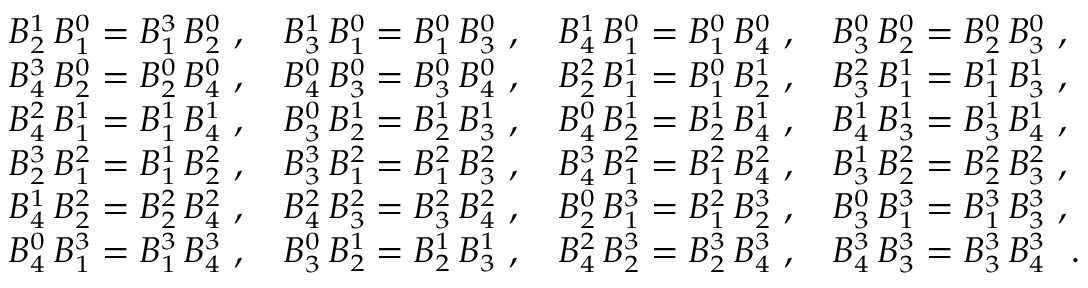Convert formula to latex. <formula><loc_0><loc_0><loc_500><loc_500>{ \begin{array} { l l l l } { B _ { 2 } ^ { 1 } \, B _ { 1 } ^ { 0 } = B _ { 1 } ^ { 3 } \, B _ { 2 } ^ { 0 } \ , } & { B _ { 3 } ^ { 1 } \, B _ { 1 } ^ { 0 } = B _ { 1 } ^ { 0 } \, B _ { 3 } ^ { 0 } \ , } & { B _ { 4 } ^ { 1 } \, B _ { 1 } ^ { 0 } = B _ { 1 } ^ { 0 } \, B _ { 4 } ^ { 0 } \ , } & { B _ { 3 } ^ { 0 } \, B _ { 2 } ^ { 0 } = B _ { 2 } ^ { 0 } \, B _ { 3 } ^ { 0 } \ , } \\ { B _ { 4 } ^ { 3 } \, B _ { 2 } ^ { 0 } = B _ { 2 } ^ { 0 } \, B _ { 4 } ^ { 0 } \ , } & { B _ { 4 } ^ { 0 } \, B _ { 3 } ^ { 0 } = B _ { 3 } ^ { 0 } \, B _ { 4 } ^ { 0 } \ , } & { B _ { 2 } ^ { 2 } \, B _ { 1 } ^ { 1 } = B _ { 1 } ^ { 0 } \, B _ { 2 } ^ { 1 } \ , } & { B _ { 3 } ^ { 2 } \, B _ { 1 } ^ { 1 } = B _ { 1 } ^ { 1 } \, B _ { 3 } ^ { 1 } \ , } \\ { B _ { 4 } ^ { 2 } \, B _ { 1 } ^ { 1 } = B _ { 1 } ^ { 1 } \, B _ { 4 } ^ { 1 } \ , } & { B _ { 3 } ^ { 0 } \, B _ { 2 } ^ { 1 } = B _ { 2 } ^ { 1 } \, B _ { 3 } ^ { 1 } \ , } & { B _ { 4 } ^ { 0 } \, B _ { 2 } ^ { 1 } = B _ { 2 } ^ { 1 } \, B _ { 4 } ^ { 1 } \ , } & { B _ { 4 } ^ { 1 } \, B _ { 3 } ^ { 1 } = B _ { 3 } ^ { 1 } \, B _ { 4 } ^ { 1 } \ , } \\ { B _ { 2 } ^ { 3 } \, B _ { 1 } ^ { 2 } = B _ { 1 } ^ { 1 } \, B _ { 2 } ^ { 2 } \ , } & { B _ { 3 } ^ { 3 } \, B _ { 1 } ^ { 2 } = B _ { 1 } ^ { 2 } \, B _ { 3 } ^ { 2 } \ , } & { B _ { 4 } ^ { 3 } \, B _ { 1 } ^ { 2 } = B _ { 1 } ^ { 2 } \, B _ { 4 } ^ { 2 } \ , } & { B _ { 3 } ^ { 1 } \, B _ { 2 } ^ { 2 } = B _ { 2 } ^ { 2 } \, B _ { 3 } ^ { 2 } \ , } \\ { B _ { 4 } ^ { 1 } \, B _ { 2 } ^ { 2 } = B _ { 2 } ^ { 2 } \, B _ { 4 } ^ { 2 } \ , } & { B _ { 4 } ^ { 2 } \, B _ { 3 } ^ { 2 } = B _ { 3 } ^ { 2 } \, B _ { 4 } ^ { 2 } \ , } & { B _ { 2 } ^ { 0 } \, B _ { 1 } ^ { 3 } = B _ { 1 } ^ { 2 } \, B _ { 2 } ^ { 3 } \ , } & { B _ { 3 } ^ { 0 } \, B _ { 1 } ^ { 3 } = B _ { 1 } ^ { 3 } \, B _ { 3 } ^ { 3 } \ , } \\ { B _ { 4 } ^ { 0 } \, B _ { 1 } ^ { 3 } = B _ { 1 } ^ { 3 } \, B _ { 4 } ^ { 3 } \ , } & { B _ { 3 } ^ { 0 } \, B _ { 2 } ^ { 1 } = B _ { 2 } ^ { 1 } \, B _ { 3 } ^ { 1 } \ , } & { B _ { 4 } ^ { 2 } \, B _ { 2 } ^ { 3 } = B _ { 2 } ^ { 3 } \, B _ { 4 } ^ { 3 } \ , } & { B _ { 4 } ^ { 3 } \, B _ { 3 } ^ { 3 } = B _ { 3 } ^ { 3 } \, B _ { 4 } ^ { 3 } \ \ . } \end{array} }</formula> 